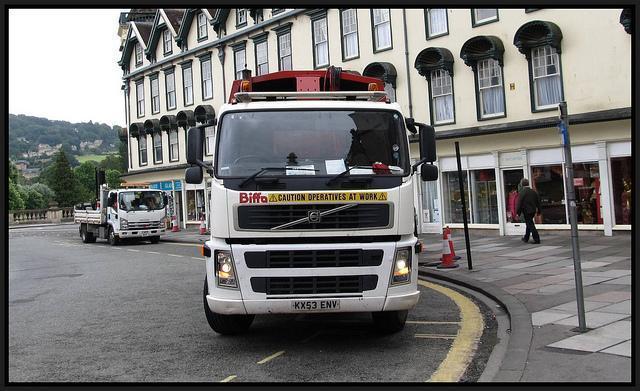How many trucks can be seen?
Give a very brief answer. 2. 